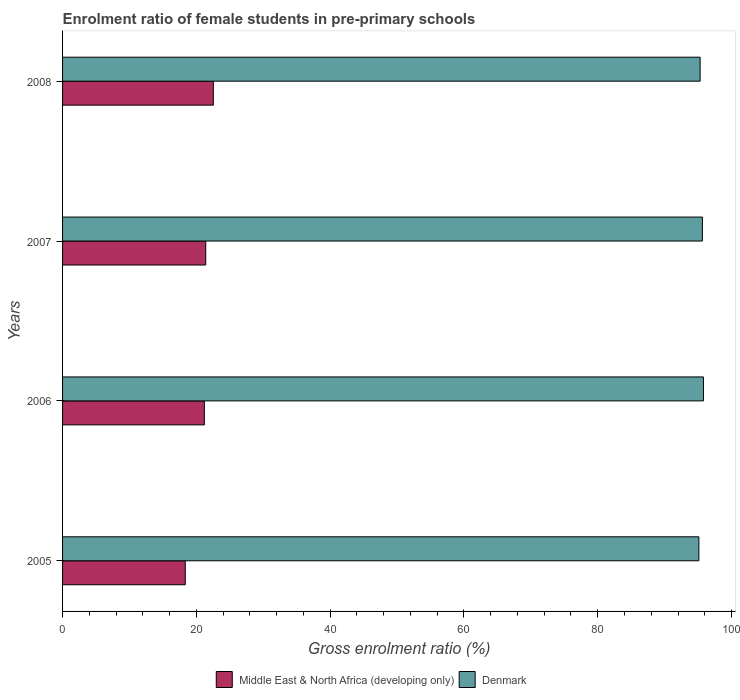How many different coloured bars are there?
Your response must be concise. 2. How many bars are there on the 2nd tick from the bottom?
Provide a succinct answer. 2. In how many cases, is the number of bars for a given year not equal to the number of legend labels?
Give a very brief answer. 0. What is the enrolment ratio of female students in pre-primary schools in Denmark in 2007?
Your answer should be very brief. 95.65. Across all years, what is the maximum enrolment ratio of female students in pre-primary schools in Denmark?
Provide a succinct answer. 95.8. Across all years, what is the minimum enrolment ratio of female students in pre-primary schools in Middle East & North Africa (developing only)?
Your answer should be very brief. 18.34. In which year was the enrolment ratio of female students in pre-primary schools in Denmark maximum?
Make the answer very short. 2006. In which year was the enrolment ratio of female students in pre-primary schools in Middle East & North Africa (developing only) minimum?
Offer a terse response. 2005. What is the total enrolment ratio of female students in pre-primary schools in Middle East & North Africa (developing only) in the graph?
Ensure brevity in your answer.  83.48. What is the difference between the enrolment ratio of female students in pre-primary schools in Middle East & North Africa (developing only) in 2006 and that in 2007?
Provide a short and direct response. -0.21. What is the difference between the enrolment ratio of female students in pre-primary schools in Denmark in 2006 and the enrolment ratio of female students in pre-primary schools in Middle East & North Africa (developing only) in 2007?
Make the answer very short. 74.4. What is the average enrolment ratio of female students in pre-primary schools in Middle East & North Africa (developing only) per year?
Your response must be concise. 20.87. In the year 2005, what is the difference between the enrolment ratio of female students in pre-primary schools in Middle East & North Africa (developing only) and enrolment ratio of female students in pre-primary schools in Denmark?
Your answer should be compact. -76.78. In how many years, is the enrolment ratio of female students in pre-primary schools in Denmark greater than 96 %?
Provide a succinct answer. 0. What is the ratio of the enrolment ratio of female students in pre-primary schools in Middle East & North Africa (developing only) in 2006 to that in 2008?
Offer a terse response. 0.94. Is the enrolment ratio of female students in pre-primary schools in Denmark in 2007 less than that in 2008?
Provide a short and direct response. No. Is the difference between the enrolment ratio of female students in pre-primary schools in Middle East & North Africa (developing only) in 2007 and 2008 greater than the difference between the enrolment ratio of female students in pre-primary schools in Denmark in 2007 and 2008?
Provide a short and direct response. No. What is the difference between the highest and the second highest enrolment ratio of female students in pre-primary schools in Denmark?
Give a very brief answer. 0.16. What is the difference between the highest and the lowest enrolment ratio of female students in pre-primary schools in Denmark?
Your answer should be very brief. 0.68. In how many years, is the enrolment ratio of female students in pre-primary schools in Middle East & North Africa (developing only) greater than the average enrolment ratio of female students in pre-primary schools in Middle East & North Africa (developing only) taken over all years?
Keep it short and to the point. 3. What does the 2nd bar from the top in 2005 represents?
Your response must be concise. Middle East & North Africa (developing only). What does the 1st bar from the bottom in 2007 represents?
Provide a short and direct response. Middle East & North Africa (developing only). How many bars are there?
Offer a terse response. 8. Are all the bars in the graph horizontal?
Provide a succinct answer. Yes. How many years are there in the graph?
Give a very brief answer. 4. What is the difference between two consecutive major ticks on the X-axis?
Make the answer very short. 20. Does the graph contain grids?
Keep it short and to the point. No. How many legend labels are there?
Provide a short and direct response. 2. How are the legend labels stacked?
Make the answer very short. Horizontal. What is the title of the graph?
Your answer should be very brief. Enrolment ratio of female students in pre-primary schools. What is the Gross enrolment ratio (%) of Middle East & North Africa (developing only) in 2005?
Provide a succinct answer. 18.34. What is the Gross enrolment ratio (%) in Denmark in 2005?
Keep it short and to the point. 95.12. What is the Gross enrolment ratio (%) in Middle East & North Africa (developing only) in 2006?
Keep it short and to the point. 21.2. What is the Gross enrolment ratio (%) of Denmark in 2006?
Offer a terse response. 95.8. What is the Gross enrolment ratio (%) in Middle East & North Africa (developing only) in 2007?
Give a very brief answer. 21.41. What is the Gross enrolment ratio (%) in Denmark in 2007?
Give a very brief answer. 95.65. What is the Gross enrolment ratio (%) in Middle East & North Africa (developing only) in 2008?
Offer a terse response. 22.54. What is the Gross enrolment ratio (%) in Denmark in 2008?
Your response must be concise. 95.31. Across all years, what is the maximum Gross enrolment ratio (%) of Middle East & North Africa (developing only)?
Make the answer very short. 22.54. Across all years, what is the maximum Gross enrolment ratio (%) of Denmark?
Offer a terse response. 95.8. Across all years, what is the minimum Gross enrolment ratio (%) of Middle East & North Africa (developing only)?
Your answer should be very brief. 18.34. Across all years, what is the minimum Gross enrolment ratio (%) of Denmark?
Keep it short and to the point. 95.12. What is the total Gross enrolment ratio (%) in Middle East & North Africa (developing only) in the graph?
Give a very brief answer. 83.48. What is the total Gross enrolment ratio (%) in Denmark in the graph?
Provide a short and direct response. 381.88. What is the difference between the Gross enrolment ratio (%) of Middle East & North Africa (developing only) in 2005 and that in 2006?
Make the answer very short. -2.86. What is the difference between the Gross enrolment ratio (%) of Denmark in 2005 and that in 2006?
Make the answer very short. -0.68. What is the difference between the Gross enrolment ratio (%) in Middle East & North Africa (developing only) in 2005 and that in 2007?
Make the answer very short. -3.07. What is the difference between the Gross enrolment ratio (%) in Denmark in 2005 and that in 2007?
Your answer should be compact. -0.52. What is the difference between the Gross enrolment ratio (%) in Middle East & North Africa (developing only) in 2005 and that in 2008?
Ensure brevity in your answer.  -4.2. What is the difference between the Gross enrolment ratio (%) in Denmark in 2005 and that in 2008?
Give a very brief answer. -0.19. What is the difference between the Gross enrolment ratio (%) in Middle East & North Africa (developing only) in 2006 and that in 2007?
Your answer should be very brief. -0.21. What is the difference between the Gross enrolment ratio (%) in Denmark in 2006 and that in 2007?
Give a very brief answer. 0.16. What is the difference between the Gross enrolment ratio (%) in Middle East & North Africa (developing only) in 2006 and that in 2008?
Ensure brevity in your answer.  -1.34. What is the difference between the Gross enrolment ratio (%) of Denmark in 2006 and that in 2008?
Ensure brevity in your answer.  0.5. What is the difference between the Gross enrolment ratio (%) of Middle East & North Africa (developing only) in 2007 and that in 2008?
Give a very brief answer. -1.13. What is the difference between the Gross enrolment ratio (%) of Denmark in 2007 and that in 2008?
Give a very brief answer. 0.34. What is the difference between the Gross enrolment ratio (%) of Middle East & North Africa (developing only) in 2005 and the Gross enrolment ratio (%) of Denmark in 2006?
Provide a short and direct response. -77.47. What is the difference between the Gross enrolment ratio (%) of Middle East & North Africa (developing only) in 2005 and the Gross enrolment ratio (%) of Denmark in 2007?
Provide a short and direct response. -77.31. What is the difference between the Gross enrolment ratio (%) of Middle East & North Africa (developing only) in 2005 and the Gross enrolment ratio (%) of Denmark in 2008?
Your answer should be very brief. -76.97. What is the difference between the Gross enrolment ratio (%) of Middle East & North Africa (developing only) in 2006 and the Gross enrolment ratio (%) of Denmark in 2007?
Offer a terse response. -74.45. What is the difference between the Gross enrolment ratio (%) in Middle East & North Africa (developing only) in 2006 and the Gross enrolment ratio (%) in Denmark in 2008?
Provide a succinct answer. -74.11. What is the difference between the Gross enrolment ratio (%) of Middle East & North Africa (developing only) in 2007 and the Gross enrolment ratio (%) of Denmark in 2008?
Provide a short and direct response. -73.9. What is the average Gross enrolment ratio (%) in Middle East & North Africa (developing only) per year?
Offer a terse response. 20.87. What is the average Gross enrolment ratio (%) of Denmark per year?
Give a very brief answer. 95.47. In the year 2005, what is the difference between the Gross enrolment ratio (%) in Middle East & North Africa (developing only) and Gross enrolment ratio (%) in Denmark?
Make the answer very short. -76.78. In the year 2006, what is the difference between the Gross enrolment ratio (%) in Middle East & North Africa (developing only) and Gross enrolment ratio (%) in Denmark?
Your answer should be compact. -74.61. In the year 2007, what is the difference between the Gross enrolment ratio (%) in Middle East & North Africa (developing only) and Gross enrolment ratio (%) in Denmark?
Your answer should be compact. -74.24. In the year 2008, what is the difference between the Gross enrolment ratio (%) of Middle East & North Africa (developing only) and Gross enrolment ratio (%) of Denmark?
Ensure brevity in your answer.  -72.77. What is the ratio of the Gross enrolment ratio (%) of Middle East & North Africa (developing only) in 2005 to that in 2006?
Offer a terse response. 0.87. What is the ratio of the Gross enrolment ratio (%) of Middle East & North Africa (developing only) in 2005 to that in 2007?
Give a very brief answer. 0.86. What is the ratio of the Gross enrolment ratio (%) of Denmark in 2005 to that in 2007?
Give a very brief answer. 0.99. What is the ratio of the Gross enrolment ratio (%) in Middle East & North Africa (developing only) in 2005 to that in 2008?
Ensure brevity in your answer.  0.81. What is the ratio of the Gross enrolment ratio (%) of Denmark in 2005 to that in 2008?
Provide a short and direct response. 1. What is the ratio of the Gross enrolment ratio (%) of Middle East & North Africa (developing only) in 2006 to that in 2007?
Give a very brief answer. 0.99. What is the ratio of the Gross enrolment ratio (%) of Middle East & North Africa (developing only) in 2006 to that in 2008?
Your answer should be compact. 0.94. What is the ratio of the Gross enrolment ratio (%) of Denmark in 2006 to that in 2008?
Keep it short and to the point. 1.01. What is the ratio of the Gross enrolment ratio (%) in Middle East & North Africa (developing only) in 2007 to that in 2008?
Your answer should be very brief. 0.95. What is the difference between the highest and the second highest Gross enrolment ratio (%) of Middle East & North Africa (developing only)?
Ensure brevity in your answer.  1.13. What is the difference between the highest and the second highest Gross enrolment ratio (%) of Denmark?
Offer a very short reply. 0.16. What is the difference between the highest and the lowest Gross enrolment ratio (%) in Middle East & North Africa (developing only)?
Provide a short and direct response. 4.2. What is the difference between the highest and the lowest Gross enrolment ratio (%) in Denmark?
Provide a short and direct response. 0.68. 